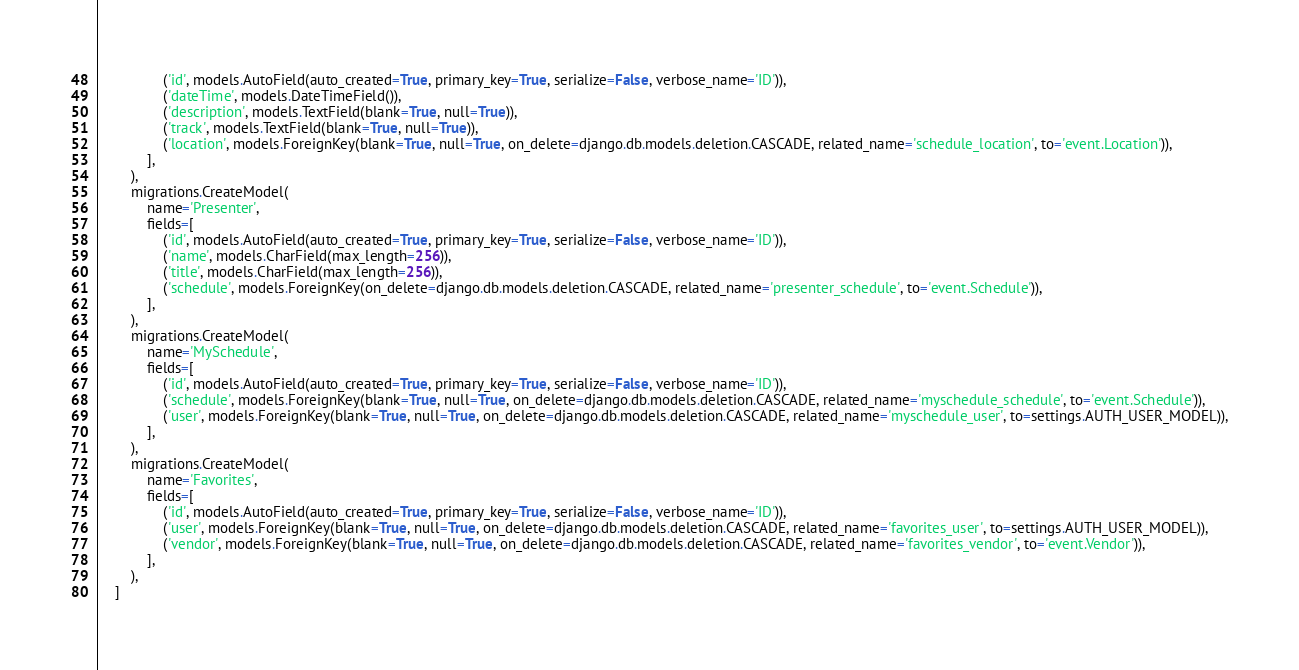Convert code to text. <code><loc_0><loc_0><loc_500><loc_500><_Python_>                ('id', models.AutoField(auto_created=True, primary_key=True, serialize=False, verbose_name='ID')),
                ('dateTime', models.DateTimeField()),
                ('description', models.TextField(blank=True, null=True)),
                ('track', models.TextField(blank=True, null=True)),
                ('location', models.ForeignKey(blank=True, null=True, on_delete=django.db.models.deletion.CASCADE, related_name='schedule_location', to='event.Location')),
            ],
        ),
        migrations.CreateModel(
            name='Presenter',
            fields=[
                ('id', models.AutoField(auto_created=True, primary_key=True, serialize=False, verbose_name='ID')),
                ('name', models.CharField(max_length=256)),
                ('title', models.CharField(max_length=256)),
                ('schedule', models.ForeignKey(on_delete=django.db.models.deletion.CASCADE, related_name='presenter_schedule', to='event.Schedule')),
            ],
        ),
        migrations.CreateModel(
            name='MySchedule',
            fields=[
                ('id', models.AutoField(auto_created=True, primary_key=True, serialize=False, verbose_name='ID')),
                ('schedule', models.ForeignKey(blank=True, null=True, on_delete=django.db.models.deletion.CASCADE, related_name='myschedule_schedule', to='event.Schedule')),
                ('user', models.ForeignKey(blank=True, null=True, on_delete=django.db.models.deletion.CASCADE, related_name='myschedule_user', to=settings.AUTH_USER_MODEL)),
            ],
        ),
        migrations.CreateModel(
            name='Favorites',
            fields=[
                ('id', models.AutoField(auto_created=True, primary_key=True, serialize=False, verbose_name='ID')),
                ('user', models.ForeignKey(blank=True, null=True, on_delete=django.db.models.deletion.CASCADE, related_name='favorites_user', to=settings.AUTH_USER_MODEL)),
                ('vendor', models.ForeignKey(blank=True, null=True, on_delete=django.db.models.deletion.CASCADE, related_name='favorites_vendor', to='event.Vendor')),
            ],
        ),
    ]
</code> 